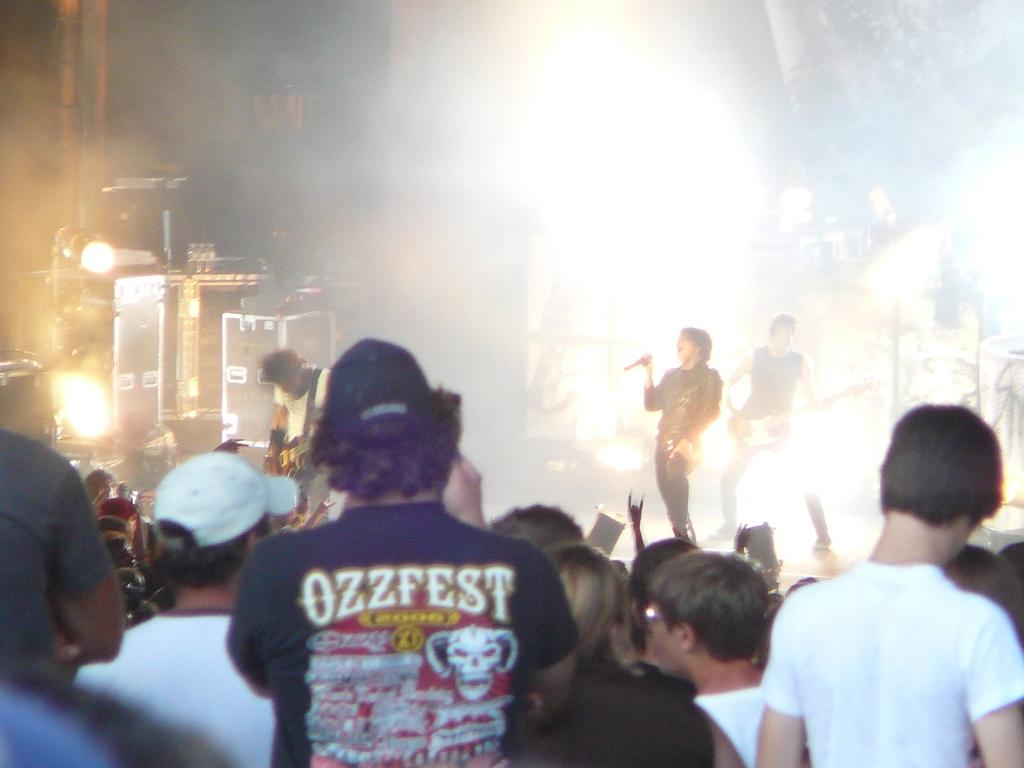How many people are present in the image? There are many people in the image. What are the people wearing? The people are wearing clothes. Are there any accessories visible on some people? Yes, some people are wearing caps. What musical instrument can be seen in the image? There is a guitar in the image. Are there any other items related to music in the image? Yes, there is a microphone and other musical instruments in the image. What can be seen in the background of the image? There are lights in the image. How many bricks are visible in the image? There are no bricks present in the image. What type of dogs can be seen playing with a seed in the image? There are no dogs or seeds present in the image. 